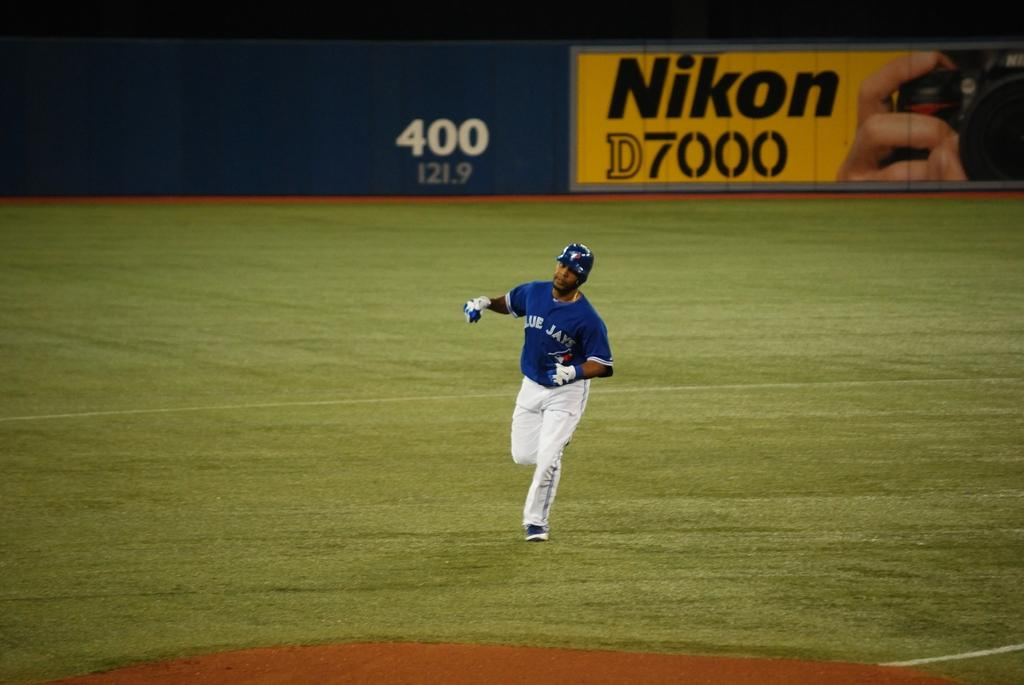<image>
Write a terse but informative summary of the picture. the Blue Jay player is in front of a Nikon D7000 board 